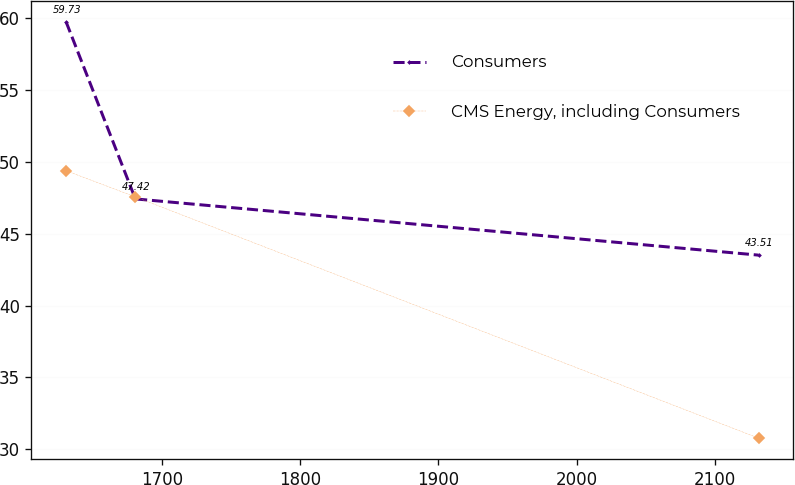Convert chart. <chart><loc_0><loc_0><loc_500><loc_500><line_chart><ecel><fcel>Consumers<fcel>CMS Energy, including Consumers<nl><fcel>1630.31<fcel>59.73<fcel>49.38<nl><fcel>1680.47<fcel>47.42<fcel>47.56<nl><fcel>2131.88<fcel>43.51<fcel>30.78<nl></chart> 